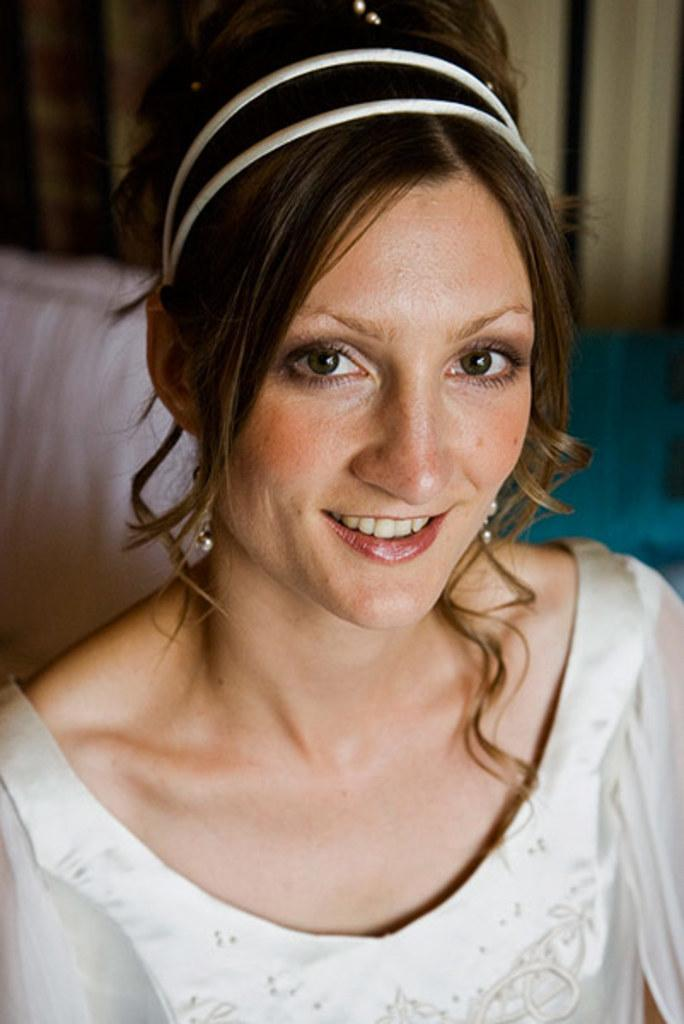Who or what is the main subject in the image? There is a person in the image. Can you describe the person's attire? The person is wearing a white dress. What can be seen in the background of the image? There are objects in the background of the image. What colors are some of the objects in the background? Some of the objects in the background are pink and green. What type of pancake is the person holding in the image? There is no pancake present in the image. Can you describe the person's wrist in the image? The image does not provide enough detail to describe the person's wrist. 